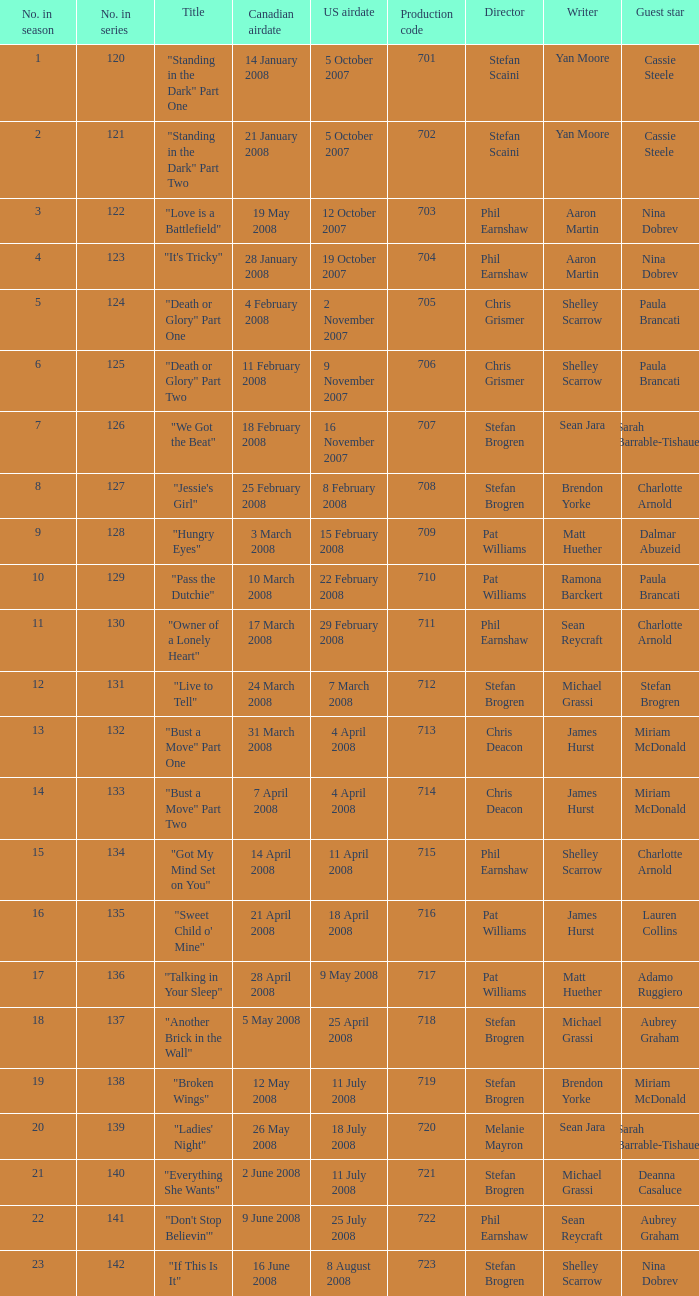The episode titled "don't stop believin'" was what highest number of the season? 22.0. 